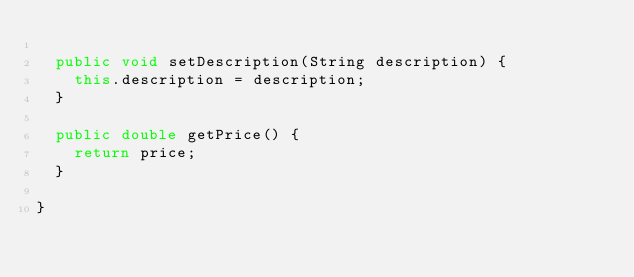Convert code to text. <code><loc_0><loc_0><loc_500><loc_500><_Java_>
	public void setDescription(String description) {
		this.description = description;
	}

	public double getPrice() {
		return price;
	}

}
</code> 